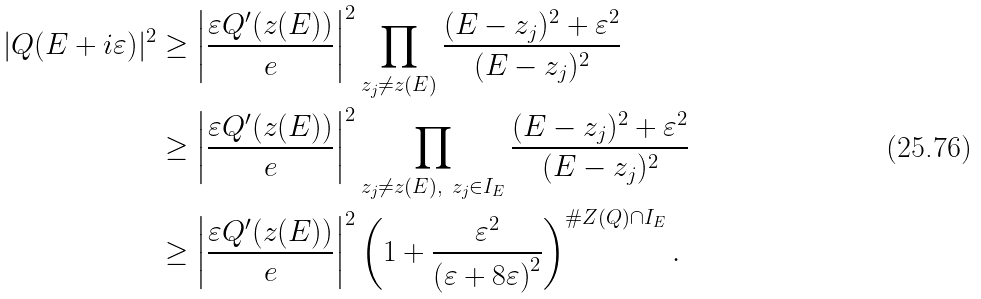Convert formula to latex. <formula><loc_0><loc_0><loc_500><loc_500>| Q ( E + i \varepsilon ) | ^ { 2 } & \geq \left | \frac { \varepsilon Q ^ { \prime } ( z ( E ) ) } { e } \right | ^ { 2 } \prod _ { z _ { j } \neq z ( E ) } \frac { ( E - z _ { j } ) ^ { 2 } + \varepsilon ^ { 2 } } { ( E - z _ { j } ) ^ { 2 } } \\ & \geq \left | \frac { \varepsilon Q ^ { \prime } ( z ( E ) ) } { e } \right | ^ { 2 } \prod _ { z _ { j } \neq z ( E ) , \ z _ { j } \in I _ { E } } \frac { ( E - z _ { j } ) ^ { 2 } + \varepsilon ^ { 2 } } { ( E - z _ { j } ) ^ { 2 } } \\ & \geq \left | \frac { \varepsilon Q ^ { \prime } ( z ( E ) ) } { e } \right | ^ { 2 } \left ( 1 + \frac { \varepsilon ^ { 2 } } { \left ( \varepsilon + 8 \varepsilon \right ) ^ { 2 } } \right ) ^ { \# Z ( Q ) \cap I _ { E } } .</formula> 